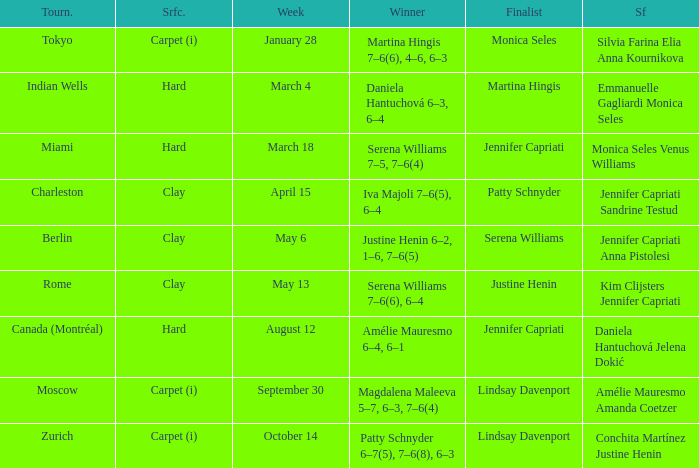What tournament had finalist Monica Seles? Tokyo. 